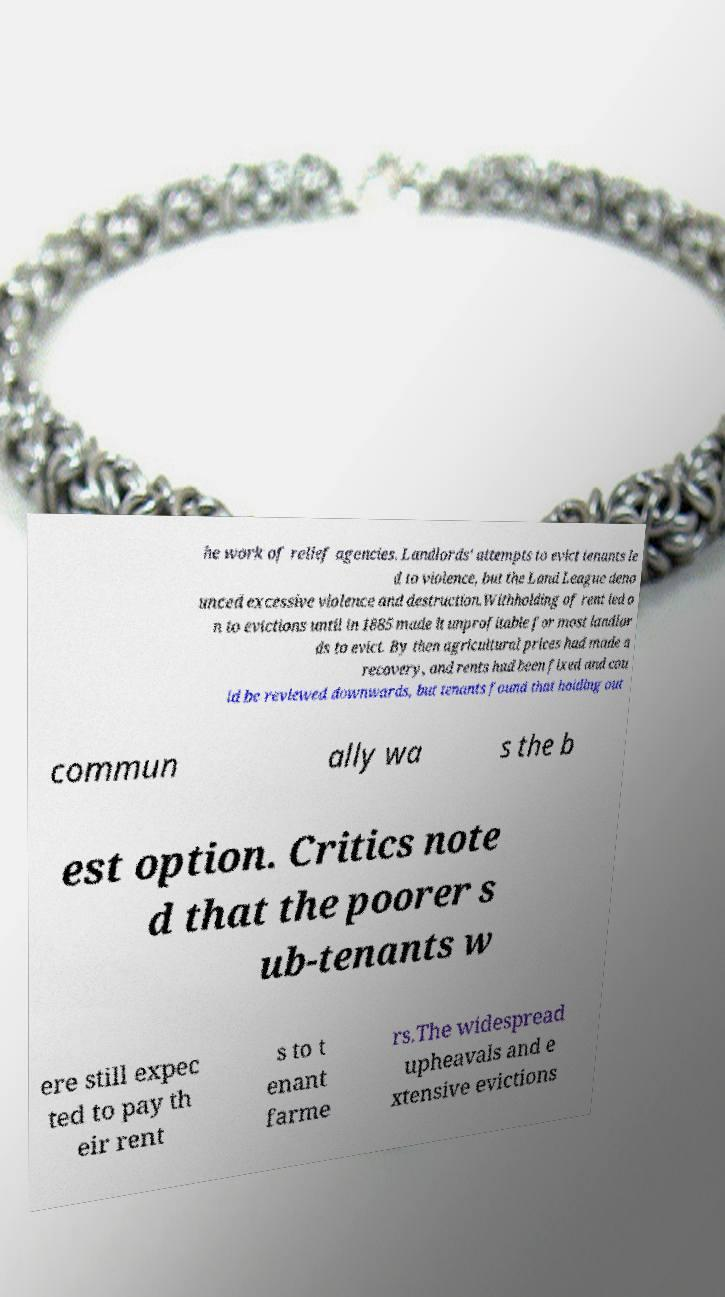I need the written content from this picture converted into text. Can you do that? he work of relief agencies. Landlords' attempts to evict tenants le d to violence, but the Land League deno unced excessive violence and destruction.Withholding of rent led o n to evictions until in 1885 made it unprofitable for most landlor ds to evict. By then agricultural prices had made a recovery, and rents had been fixed and cou ld be reviewed downwards, but tenants found that holding out commun ally wa s the b est option. Critics note d that the poorer s ub-tenants w ere still expec ted to pay th eir rent s to t enant farme rs.The widespread upheavals and e xtensive evictions 